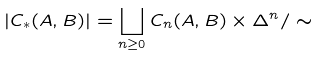<formula> <loc_0><loc_0><loc_500><loc_500>| C _ { \ast } ( A , B ) | = \coprod _ { n \geq 0 } C _ { n } ( A , B ) \times \Delta ^ { n } / \sim</formula> 